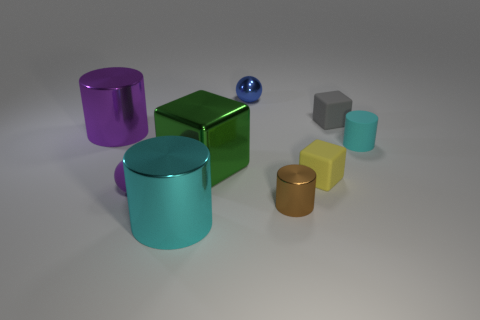Add 1 large yellow metallic blocks. How many objects exist? 10 Subtract all spheres. How many objects are left? 7 Add 2 rubber spheres. How many rubber spheres are left? 3 Add 1 cyan metal objects. How many cyan metal objects exist? 2 Subtract 0 green balls. How many objects are left? 9 Subtract all green objects. Subtract all shiny cubes. How many objects are left? 7 